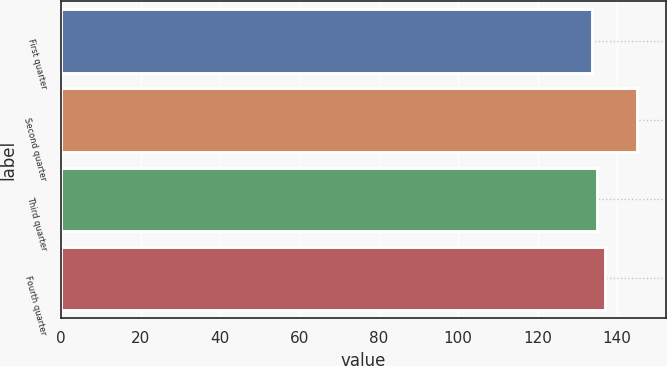Convert chart to OTSL. <chart><loc_0><loc_0><loc_500><loc_500><bar_chart><fcel>First quarter<fcel>Second quarter<fcel>Third quarter<fcel>Fourth quarter<nl><fcel>133.82<fcel>145.13<fcel>134.95<fcel>137.1<nl></chart> 